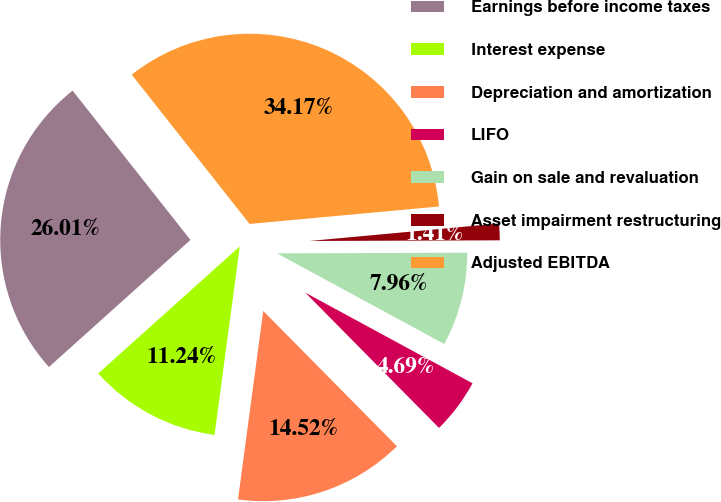<chart> <loc_0><loc_0><loc_500><loc_500><pie_chart><fcel>Earnings before income taxes<fcel>Interest expense<fcel>Depreciation and amortization<fcel>LIFO<fcel>Gain on sale and revaluation<fcel>Asset impairment restructuring<fcel>Adjusted EBITDA<nl><fcel>26.01%<fcel>11.24%<fcel>14.52%<fcel>4.69%<fcel>7.96%<fcel>1.41%<fcel>34.17%<nl></chart> 